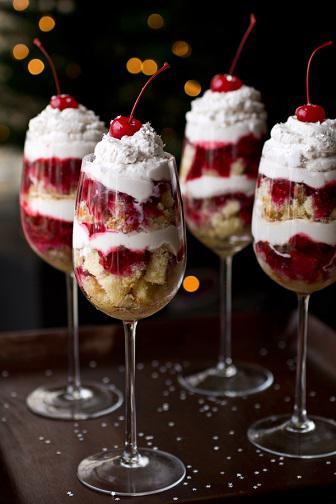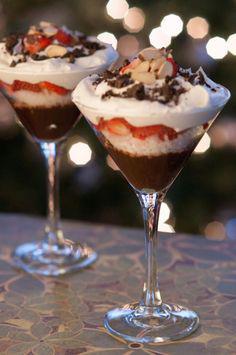The first image is the image on the left, the second image is the image on the right. Considering the images on both sides, is "An image shows a pair of martini-style glasses containing desserts that include a red layer surrounded by white cream, and a bottom chocolate layer." valid? Answer yes or no. Yes. The first image is the image on the left, the second image is the image on the right. Evaluate the accuracy of this statement regarding the images: "There are exactly four layered desserts in cups.". Is it true? Answer yes or no. No. 